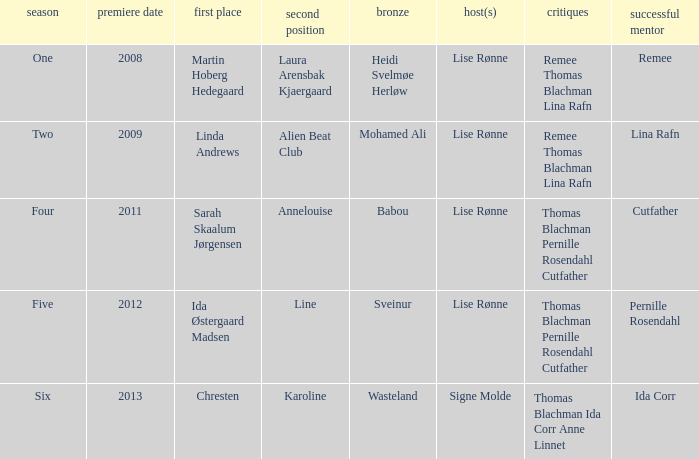Who was the runner-up when Mohamed Ali got third? Alien Beat Club. 